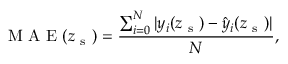Convert formula to latex. <formula><loc_0><loc_0><loc_500><loc_500>M A E ( z _ { s } ) = \frac { \sum _ { i = 0 } ^ { N } | y _ { i } ( z _ { s } ) - \hat { y } _ { i } ( z _ { s } ) | } { N } ,</formula> 